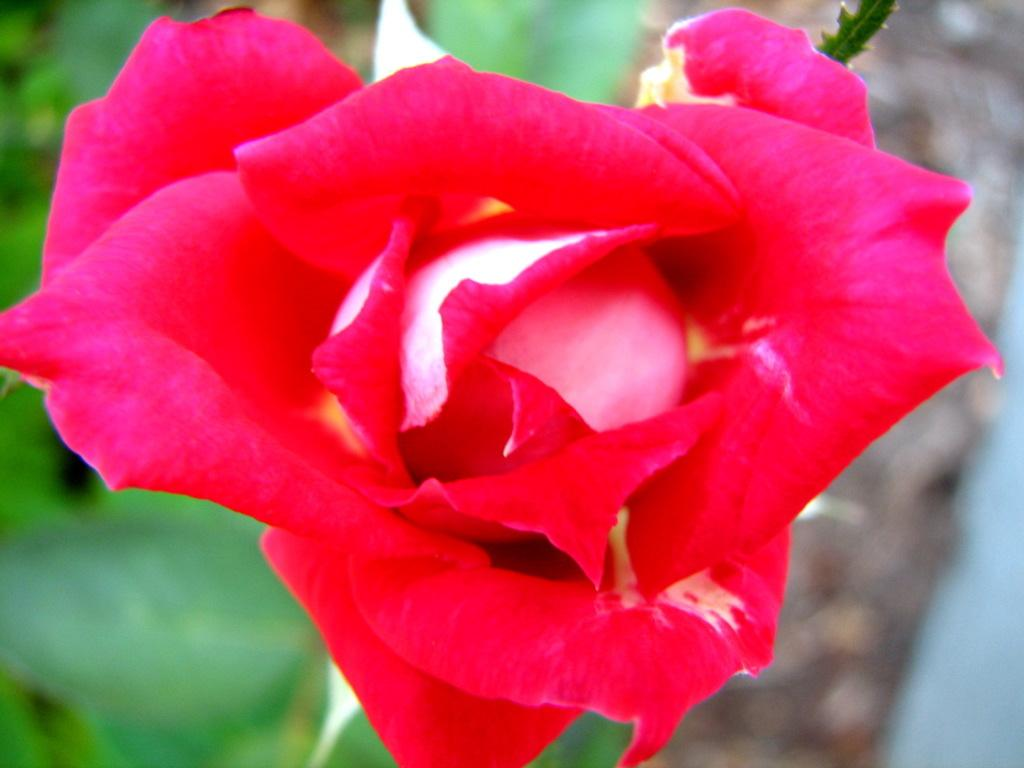What is the main subject in the foreground of the picture? There is a red rose in the foreground of the picture. Where is the red rose located? The red rose is on a plant. What can be seen in the background of the image? The background of the image is green and blurred. What type of nail is being used by the judge in the image? There is no judge or nail present in the image; it features a red rose on a plant with a green and blurred background. 